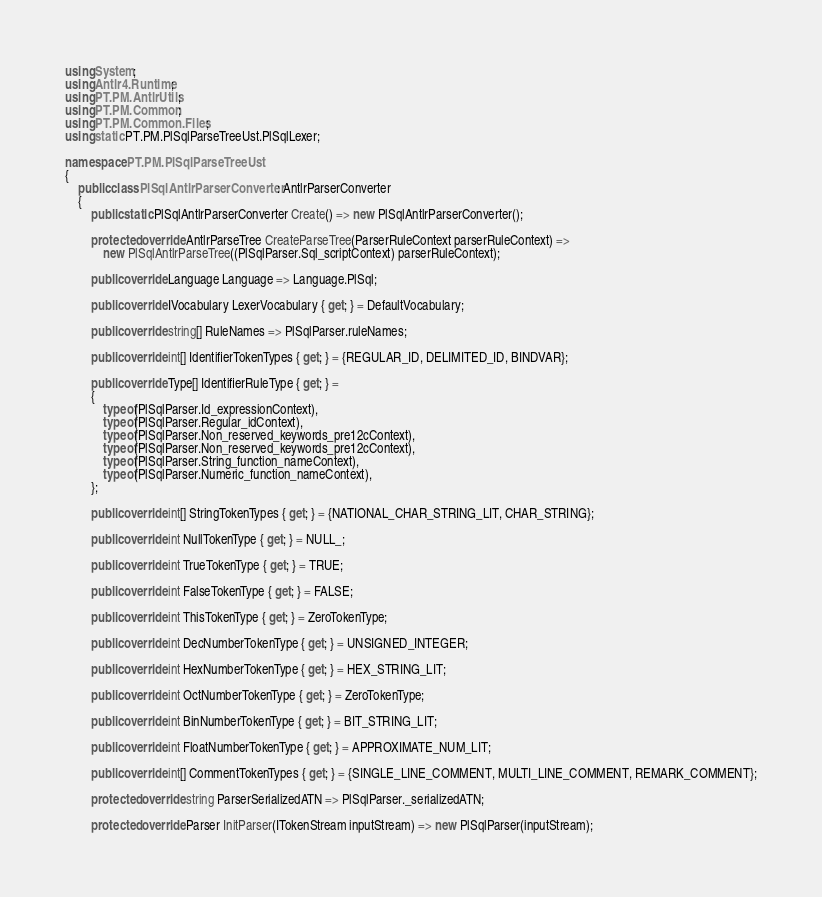<code> <loc_0><loc_0><loc_500><loc_500><_C#_>using System;
using Antlr4.Runtime;
using PT.PM.AntlrUtils;
using PT.PM.Common;
using PT.PM.Common.Files;
using static PT.PM.PlSqlParseTreeUst.PlSqlLexer;

namespace PT.PM.PlSqlParseTreeUst
{
    public class PlSqlAntlrParserConverter : AntlrParserConverter
    {
        public static PlSqlAntlrParserConverter Create() => new PlSqlAntlrParserConverter();

        protected override AntlrParseTree CreateParseTree(ParserRuleContext parserRuleContext) =>
            new PlSqlAntlrParseTree((PlSqlParser.Sql_scriptContext) parserRuleContext);

        public override Language Language => Language.PlSql;

        public override IVocabulary LexerVocabulary { get; } = DefaultVocabulary;

        public override string[] RuleNames => PlSqlParser.ruleNames;

        public override int[] IdentifierTokenTypes { get; } = {REGULAR_ID, DELIMITED_ID, BINDVAR};

        public override Type[] IdentifierRuleType { get; } =
        {
            typeof(PlSqlParser.Id_expressionContext),
            typeof(PlSqlParser.Regular_idContext),
            typeof(PlSqlParser.Non_reserved_keywords_pre12cContext),
            typeof(PlSqlParser.Non_reserved_keywords_pre12cContext),
            typeof(PlSqlParser.String_function_nameContext),
            typeof(PlSqlParser.Numeric_function_nameContext),
        };

        public override int[] StringTokenTypes { get; } = {NATIONAL_CHAR_STRING_LIT, CHAR_STRING};

        public override int NullTokenType { get; } = NULL_;

        public override int TrueTokenType { get; } = TRUE;

        public override int FalseTokenType { get; } = FALSE;

        public override int ThisTokenType { get; } = ZeroTokenType;

        public override int DecNumberTokenType { get; } = UNSIGNED_INTEGER;

        public override int HexNumberTokenType { get; } = HEX_STRING_LIT;

        public override int OctNumberTokenType { get; } = ZeroTokenType;

        public override int BinNumberTokenType { get; } = BIT_STRING_LIT;

        public override int FloatNumberTokenType { get; } = APPROXIMATE_NUM_LIT;

        public override int[] CommentTokenTypes { get; } = {SINGLE_LINE_COMMENT, MULTI_LINE_COMMENT, REMARK_COMMENT};

        protected override string ParserSerializedATN => PlSqlParser._serializedATN;

        protected override Parser InitParser(ITokenStream inputStream) => new PlSqlParser(inputStream);
</code> 